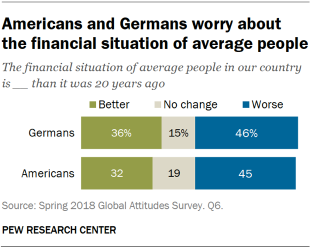Indicate a few pertinent items in this graphic. The value of 'Worse' in German is 0.46. The median of all American bars is smaller than the largest green bar. 